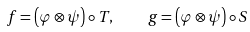Convert formula to latex. <formula><loc_0><loc_0><loc_500><loc_500>f = \left ( \varphi \otimes \psi \right ) \circ T , \quad g = \left ( \varphi \otimes \psi \right ) \circ S</formula> 